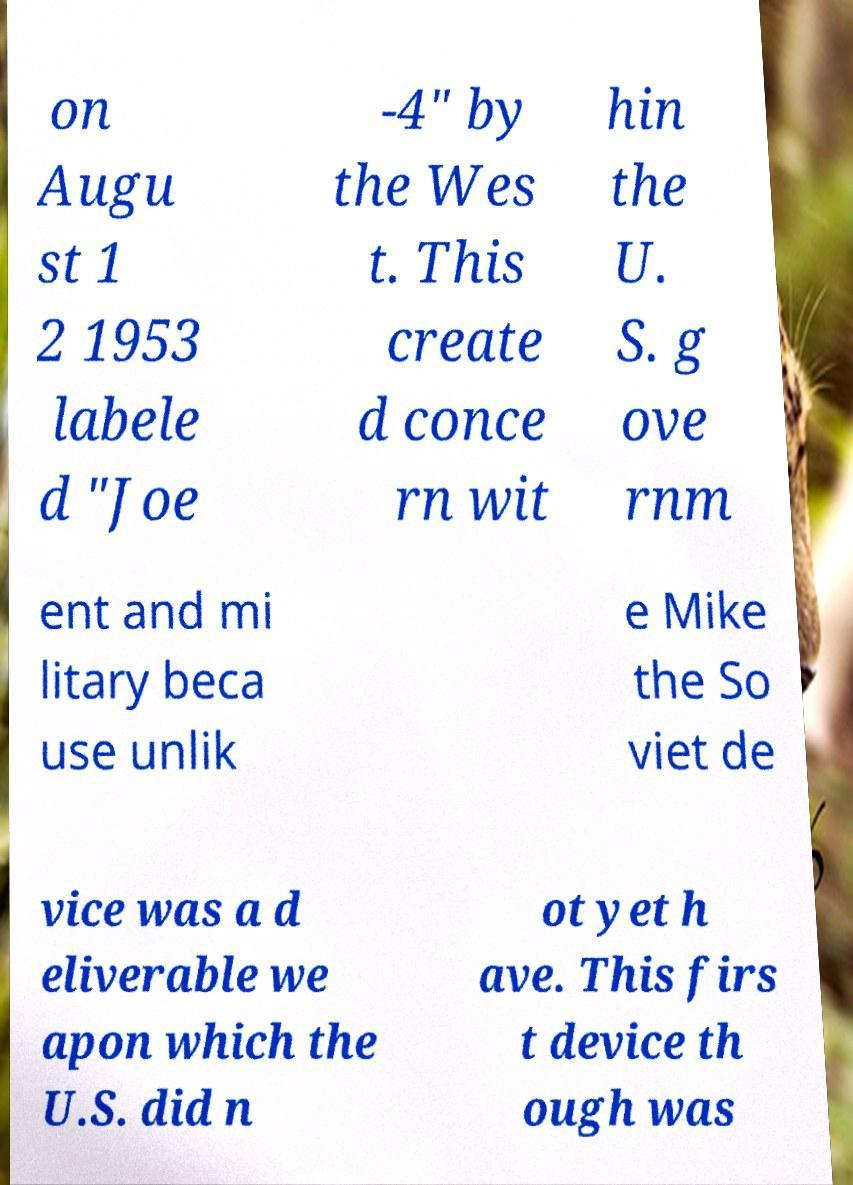For documentation purposes, I need the text within this image transcribed. Could you provide that? on Augu st 1 2 1953 labele d "Joe -4" by the Wes t. This create d conce rn wit hin the U. S. g ove rnm ent and mi litary beca use unlik e Mike the So viet de vice was a d eliverable we apon which the U.S. did n ot yet h ave. This firs t device th ough was 